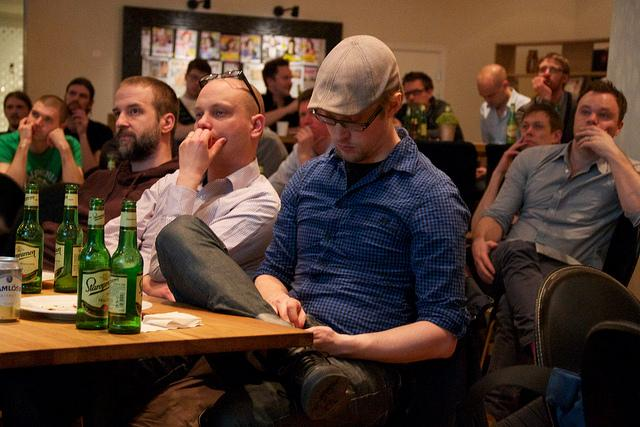How many people in this picture need to see an optometrist regularly? Please explain your reasoning. four. There are four people. 